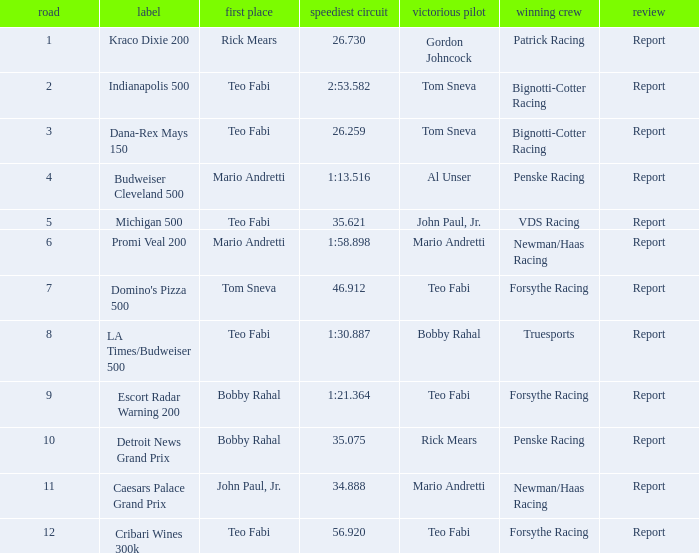Which teams won when Bobby Rahal was their winning driver? Truesports. 